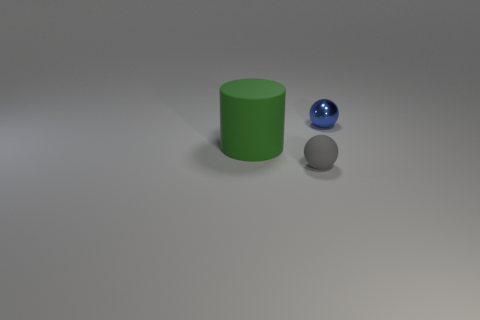Is there a light source in the image? If so, what direction is it coming from? Yes, there appears to be a light source off to the side, casting a shadow to the right of the objects, which suggests that the light is coming from the left. 